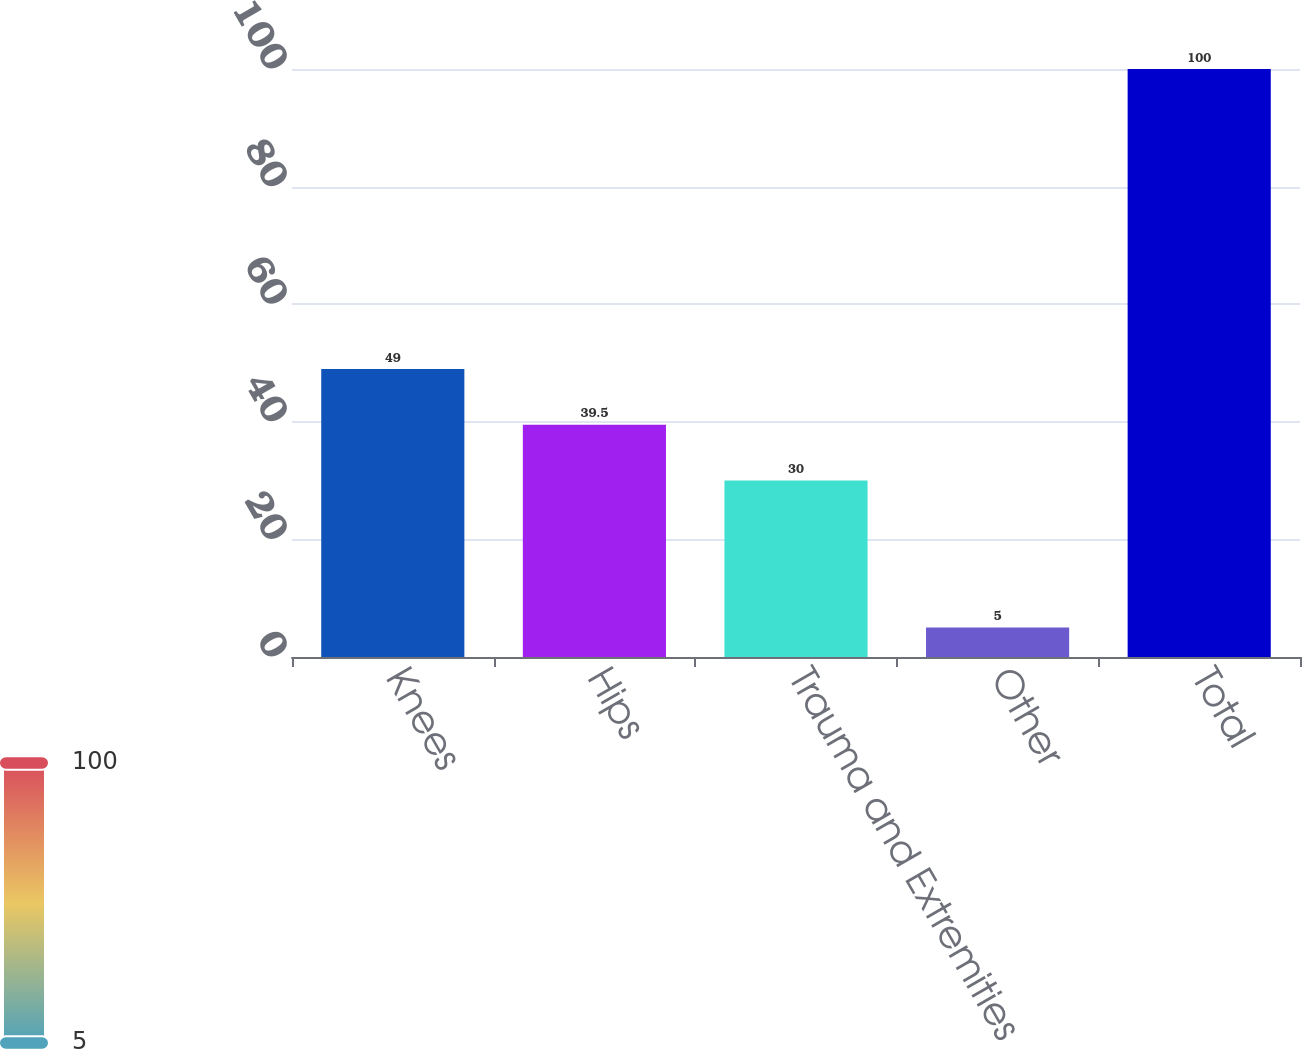Convert chart. <chart><loc_0><loc_0><loc_500><loc_500><bar_chart><fcel>Knees<fcel>Hips<fcel>Trauma and Extremities<fcel>Other<fcel>Total<nl><fcel>49<fcel>39.5<fcel>30<fcel>5<fcel>100<nl></chart> 